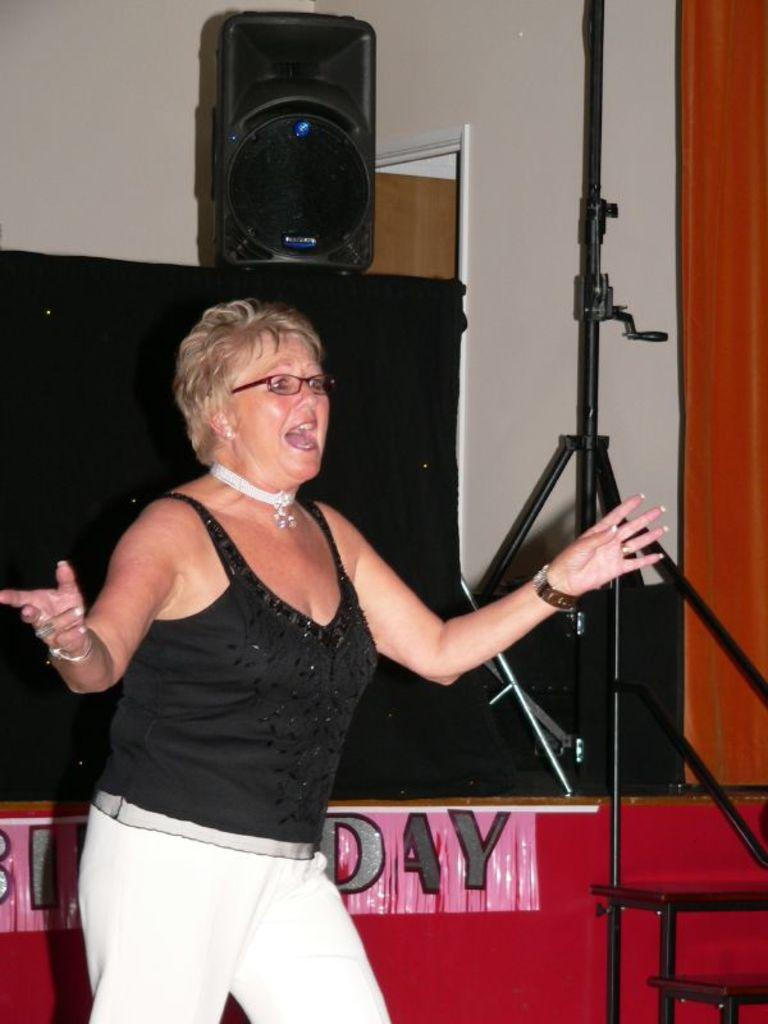<image>
Create a compact narrative representing the image presented. a lady singing in front of a sign that says day 